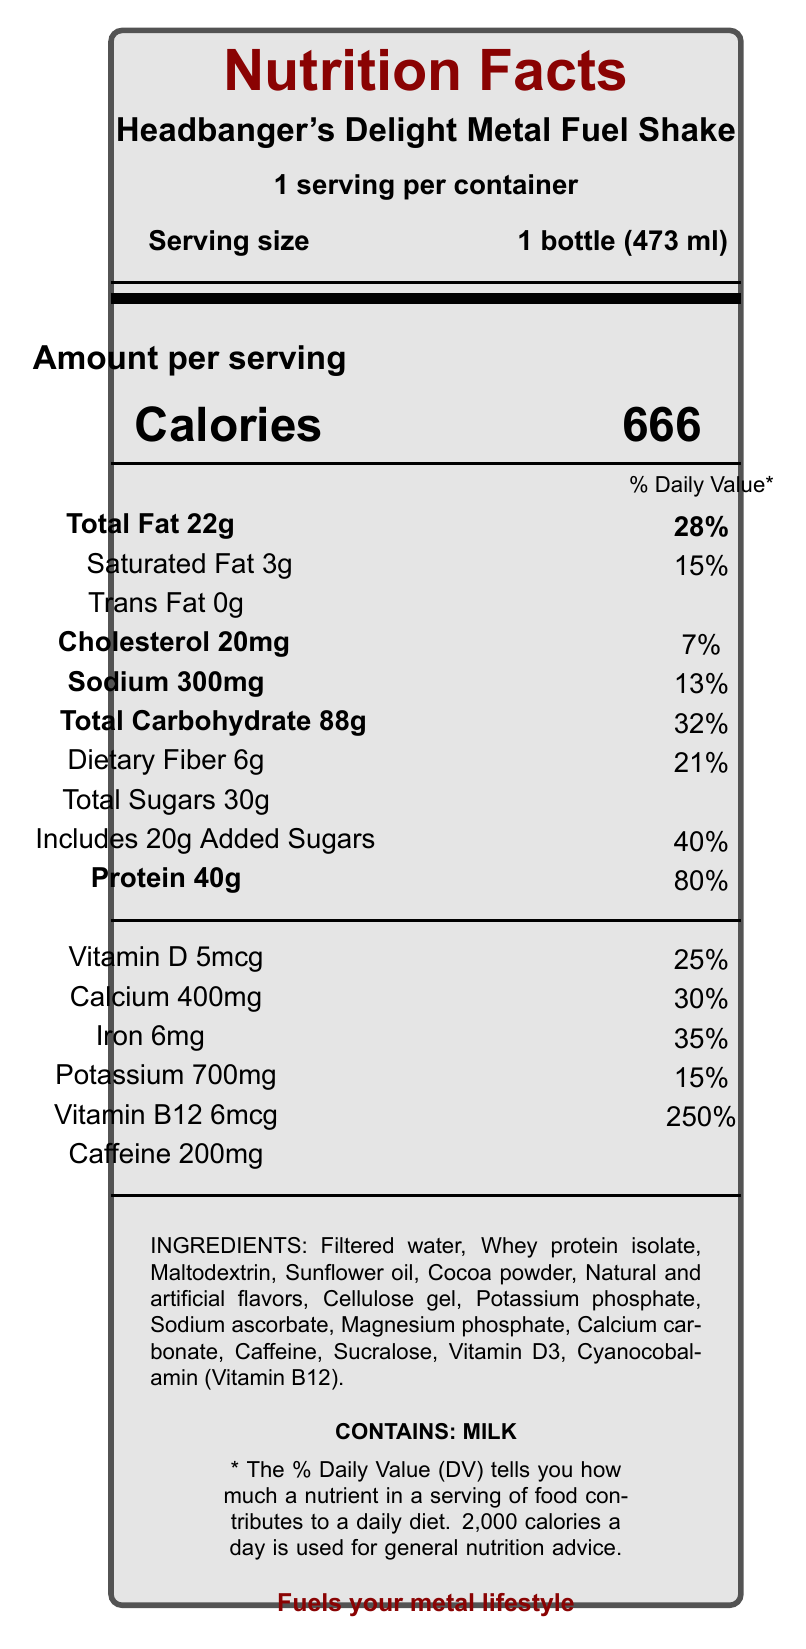what is the serving size of the Headbanger's Delight Metal Fuel Shake? The serving size is directly mentioned in the document under "Serving size."
Answer: 1 bottle (473 ml) how many calories are in one serving of the shake? The number of calories per serving is prominently displayed next to the word "Calories."
Answer: 666 what is the percentage daily value of protein in one serving? This percentage is given next to the "Protein 40g" line in the daily value section.
Answer: 80% which nutrient has the highest percentage daily value in this shake? Vitamin B12 has a daily value of 250%, which is the highest among all listed nutrients.
Answer: Vitamin B12 how much sugar is included in one serving of the drink? The total sugar content and the amount of added sugars are specified in the document.
Answer: 30g total sugars, including 20g added sugars what are the marketing claims made for this product? These claims are listed under the "marketing claims" section of the document.
Answer: Fuels your metal lifestyle; Packed with headbanging energy; Amplifies your performance; Intense flavor for intense musicians how much caffeine does the Headbanger's Delight Metal Fuel Shake contain per serving? The amount of caffeine is stated directly under the nutrient information.
Answer: 200 mg what ingredients are used in the shake? A. Milk, Sugar, Cocoa B. Whey protein isolate, Sunflower oil, Caffeine C. Water, Soy protein, Natural flavors D. Casein, Olive oil, Vitamins The ingredients listed in the document include whey protein isolate, sunflower oil, and caffeine.
Answer: B. Whey protein isolate, Sunflower oil, Caffeine what is the daily value percentage for calcium in one serving? A. 10% B. 20% C. 30% D. 40% The document specifies that calcium has a daily value of 30%.
Answer: C. 30% does the shake contain any trans fat? The trans fat content is listed as 0g in the document.
Answer: No please summarize the main points of the document. The document includes nutritional facts, ingredients, allergens, and marketing claims about the Headbanger's Delight Metal Fuel Shake.
Answer: The Headbanger's Delight Metal Fuel Shake is a meal replacement shake with a serving size of 1 bottle (473 ml). It contains 666 calories, 22g of total fat, 88g of carbohydrates, 30g of sugars (including 20g of added sugars), and 40g of protein. It provides high percentages of various daily nutrients, especially Vitamin B12 (250%). It contains caffeine (200 mg) and uses ingredients such as whey protein isolate and sunflower oil. The shake is marketed with claims like "Fuels your metal lifestyle" and "Packed with headbanging energy." The product contains milk. how much potassium does the shake contain per serving? The amount of potassium per serving is clearly specified in the document.
Answer: 700 mg are there any allergens present in the shake? If so, what are they? The document states "CONTAINS: MILK" under the ingredients section.
Answer: Yes, milk how much Vitamin D is in one serving of the shake and what is its daily value percentage? The amount of Vitamin D and its daily value percentage is listed in the nutrient section.
Answer: 5 mcg and 25% can you determine the flavor of the shake from this document? The document lists ingredients including "Natural and artificial flavors," but it does not specify the exact flavor of the shake.
Answer: Cannot be determined 